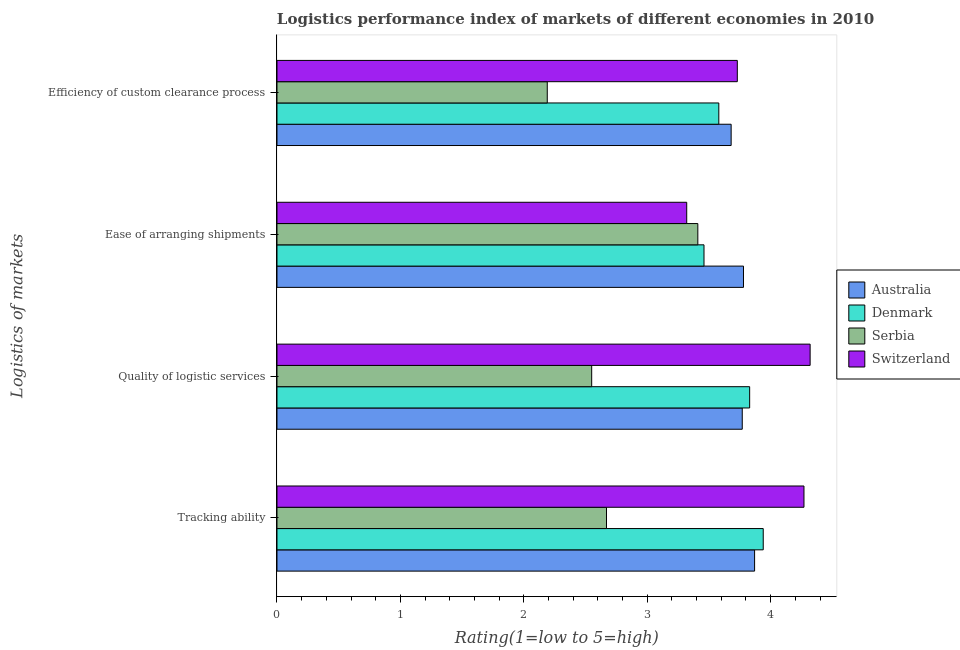Are the number of bars per tick equal to the number of legend labels?
Your response must be concise. Yes. How many bars are there on the 3rd tick from the top?
Keep it short and to the point. 4. What is the label of the 2nd group of bars from the top?
Provide a short and direct response. Ease of arranging shipments. What is the lpi rating of efficiency of custom clearance process in Australia?
Offer a very short reply. 3.68. Across all countries, what is the maximum lpi rating of tracking ability?
Provide a short and direct response. 4.27. Across all countries, what is the minimum lpi rating of efficiency of custom clearance process?
Your answer should be compact. 2.19. In which country was the lpi rating of efficiency of custom clearance process minimum?
Offer a terse response. Serbia. What is the total lpi rating of ease of arranging shipments in the graph?
Provide a succinct answer. 13.97. What is the difference between the lpi rating of quality of logistic services in Australia and that in Serbia?
Your answer should be compact. 1.22. What is the difference between the lpi rating of efficiency of custom clearance process in Serbia and the lpi rating of ease of arranging shipments in Australia?
Give a very brief answer. -1.59. What is the average lpi rating of ease of arranging shipments per country?
Your answer should be very brief. 3.49. What is the difference between the lpi rating of ease of arranging shipments and lpi rating of tracking ability in Serbia?
Your answer should be very brief. 0.74. In how many countries, is the lpi rating of ease of arranging shipments greater than 2.2 ?
Your response must be concise. 4. What is the ratio of the lpi rating of efficiency of custom clearance process in Denmark to that in Switzerland?
Ensure brevity in your answer.  0.96. Is the lpi rating of quality of logistic services in Switzerland less than that in Serbia?
Make the answer very short. No. What is the difference between the highest and the second highest lpi rating of quality of logistic services?
Your answer should be compact. 0.49. What is the difference between the highest and the lowest lpi rating of tracking ability?
Provide a succinct answer. 1.6. In how many countries, is the lpi rating of ease of arranging shipments greater than the average lpi rating of ease of arranging shipments taken over all countries?
Give a very brief answer. 1. Is it the case that in every country, the sum of the lpi rating of tracking ability and lpi rating of ease of arranging shipments is greater than the sum of lpi rating of efficiency of custom clearance process and lpi rating of quality of logistic services?
Keep it short and to the point. No. What does the 2nd bar from the top in Tracking ability represents?
Keep it short and to the point. Serbia. Is it the case that in every country, the sum of the lpi rating of tracking ability and lpi rating of quality of logistic services is greater than the lpi rating of ease of arranging shipments?
Offer a terse response. Yes. How many bars are there?
Offer a very short reply. 16. Are all the bars in the graph horizontal?
Offer a very short reply. Yes. Does the graph contain any zero values?
Offer a terse response. No. Does the graph contain grids?
Ensure brevity in your answer.  No. How many legend labels are there?
Ensure brevity in your answer.  4. What is the title of the graph?
Your response must be concise. Logistics performance index of markets of different economies in 2010. What is the label or title of the X-axis?
Provide a short and direct response. Rating(1=low to 5=high). What is the label or title of the Y-axis?
Provide a short and direct response. Logistics of markets. What is the Rating(1=low to 5=high) in Australia in Tracking ability?
Keep it short and to the point. 3.87. What is the Rating(1=low to 5=high) of Denmark in Tracking ability?
Your answer should be compact. 3.94. What is the Rating(1=low to 5=high) in Serbia in Tracking ability?
Your answer should be very brief. 2.67. What is the Rating(1=low to 5=high) in Switzerland in Tracking ability?
Ensure brevity in your answer.  4.27. What is the Rating(1=low to 5=high) in Australia in Quality of logistic services?
Offer a very short reply. 3.77. What is the Rating(1=low to 5=high) in Denmark in Quality of logistic services?
Your answer should be compact. 3.83. What is the Rating(1=low to 5=high) in Serbia in Quality of logistic services?
Give a very brief answer. 2.55. What is the Rating(1=low to 5=high) in Switzerland in Quality of logistic services?
Your response must be concise. 4.32. What is the Rating(1=low to 5=high) of Australia in Ease of arranging shipments?
Keep it short and to the point. 3.78. What is the Rating(1=low to 5=high) of Denmark in Ease of arranging shipments?
Provide a short and direct response. 3.46. What is the Rating(1=low to 5=high) in Serbia in Ease of arranging shipments?
Ensure brevity in your answer.  3.41. What is the Rating(1=low to 5=high) in Switzerland in Ease of arranging shipments?
Give a very brief answer. 3.32. What is the Rating(1=low to 5=high) in Australia in Efficiency of custom clearance process?
Offer a terse response. 3.68. What is the Rating(1=low to 5=high) of Denmark in Efficiency of custom clearance process?
Provide a short and direct response. 3.58. What is the Rating(1=low to 5=high) in Serbia in Efficiency of custom clearance process?
Keep it short and to the point. 2.19. What is the Rating(1=low to 5=high) in Switzerland in Efficiency of custom clearance process?
Keep it short and to the point. 3.73. Across all Logistics of markets, what is the maximum Rating(1=low to 5=high) of Australia?
Offer a very short reply. 3.87. Across all Logistics of markets, what is the maximum Rating(1=low to 5=high) of Denmark?
Offer a terse response. 3.94. Across all Logistics of markets, what is the maximum Rating(1=low to 5=high) in Serbia?
Your answer should be very brief. 3.41. Across all Logistics of markets, what is the maximum Rating(1=low to 5=high) in Switzerland?
Your answer should be very brief. 4.32. Across all Logistics of markets, what is the minimum Rating(1=low to 5=high) of Australia?
Offer a terse response. 3.68. Across all Logistics of markets, what is the minimum Rating(1=low to 5=high) of Denmark?
Provide a succinct answer. 3.46. Across all Logistics of markets, what is the minimum Rating(1=low to 5=high) of Serbia?
Keep it short and to the point. 2.19. Across all Logistics of markets, what is the minimum Rating(1=low to 5=high) in Switzerland?
Provide a succinct answer. 3.32. What is the total Rating(1=low to 5=high) in Denmark in the graph?
Offer a very short reply. 14.81. What is the total Rating(1=low to 5=high) of Serbia in the graph?
Offer a terse response. 10.82. What is the total Rating(1=low to 5=high) of Switzerland in the graph?
Provide a short and direct response. 15.64. What is the difference between the Rating(1=low to 5=high) of Australia in Tracking ability and that in Quality of logistic services?
Your answer should be very brief. 0.1. What is the difference between the Rating(1=low to 5=high) of Denmark in Tracking ability and that in Quality of logistic services?
Provide a succinct answer. 0.11. What is the difference between the Rating(1=low to 5=high) of Serbia in Tracking ability and that in Quality of logistic services?
Offer a very short reply. 0.12. What is the difference between the Rating(1=low to 5=high) of Switzerland in Tracking ability and that in Quality of logistic services?
Keep it short and to the point. -0.05. What is the difference between the Rating(1=low to 5=high) of Australia in Tracking ability and that in Ease of arranging shipments?
Ensure brevity in your answer.  0.09. What is the difference between the Rating(1=low to 5=high) of Denmark in Tracking ability and that in Ease of arranging shipments?
Offer a very short reply. 0.48. What is the difference between the Rating(1=low to 5=high) of Serbia in Tracking ability and that in Ease of arranging shipments?
Keep it short and to the point. -0.74. What is the difference between the Rating(1=low to 5=high) of Switzerland in Tracking ability and that in Ease of arranging shipments?
Keep it short and to the point. 0.95. What is the difference between the Rating(1=low to 5=high) in Australia in Tracking ability and that in Efficiency of custom clearance process?
Give a very brief answer. 0.19. What is the difference between the Rating(1=low to 5=high) in Denmark in Tracking ability and that in Efficiency of custom clearance process?
Provide a succinct answer. 0.36. What is the difference between the Rating(1=low to 5=high) of Serbia in Tracking ability and that in Efficiency of custom clearance process?
Offer a terse response. 0.48. What is the difference between the Rating(1=low to 5=high) of Switzerland in Tracking ability and that in Efficiency of custom clearance process?
Your answer should be very brief. 0.54. What is the difference between the Rating(1=low to 5=high) in Australia in Quality of logistic services and that in Ease of arranging shipments?
Ensure brevity in your answer.  -0.01. What is the difference between the Rating(1=low to 5=high) of Denmark in Quality of logistic services and that in Ease of arranging shipments?
Keep it short and to the point. 0.37. What is the difference between the Rating(1=low to 5=high) in Serbia in Quality of logistic services and that in Ease of arranging shipments?
Your answer should be compact. -0.86. What is the difference between the Rating(1=low to 5=high) of Switzerland in Quality of logistic services and that in Ease of arranging shipments?
Offer a very short reply. 1. What is the difference between the Rating(1=low to 5=high) in Australia in Quality of logistic services and that in Efficiency of custom clearance process?
Your answer should be very brief. 0.09. What is the difference between the Rating(1=low to 5=high) in Serbia in Quality of logistic services and that in Efficiency of custom clearance process?
Make the answer very short. 0.36. What is the difference between the Rating(1=low to 5=high) of Switzerland in Quality of logistic services and that in Efficiency of custom clearance process?
Keep it short and to the point. 0.59. What is the difference between the Rating(1=low to 5=high) of Denmark in Ease of arranging shipments and that in Efficiency of custom clearance process?
Provide a short and direct response. -0.12. What is the difference between the Rating(1=low to 5=high) of Serbia in Ease of arranging shipments and that in Efficiency of custom clearance process?
Your response must be concise. 1.22. What is the difference between the Rating(1=low to 5=high) in Switzerland in Ease of arranging shipments and that in Efficiency of custom clearance process?
Ensure brevity in your answer.  -0.41. What is the difference between the Rating(1=low to 5=high) of Australia in Tracking ability and the Rating(1=low to 5=high) of Serbia in Quality of logistic services?
Your response must be concise. 1.32. What is the difference between the Rating(1=low to 5=high) of Australia in Tracking ability and the Rating(1=low to 5=high) of Switzerland in Quality of logistic services?
Ensure brevity in your answer.  -0.45. What is the difference between the Rating(1=low to 5=high) of Denmark in Tracking ability and the Rating(1=low to 5=high) of Serbia in Quality of logistic services?
Your response must be concise. 1.39. What is the difference between the Rating(1=low to 5=high) in Denmark in Tracking ability and the Rating(1=low to 5=high) in Switzerland in Quality of logistic services?
Your answer should be very brief. -0.38. What is the difference between the Rating(1=low to 5=high) in Serbia in Tracking ability and the Rating(1=low to 5=high) in Switzerland in Quality of logistic services?
Offer a very short reply. -1.65. What is the difference between the Rating(1=low to 5=high) in Australia in Tracking ability and the Rating(1=low to 5=high) in Denmark in Ease of arranging shipments?
Your response must be concise. 0.41. What is the difference between the Rating(1=low to 5=high) in Australia in Tracking ability and the Rating(1=low to 5=high) in Serbia in Ease of arranging shipments?
Your answer should be very brief. 0.46. What is the difference between the Rating(1=low to 5=high) in Australia in Tracking ability and the Rating(1=low to 5=high) in Switzerland in Ease of arranging shipments?
Ensure brevity in your answer.  0.55. What is the difference between the Rating(1=low to 5=high) of Denmark in Tracking ability and the Rating(1=low to 5=high) of Serbia in Ease of arranging shipments?
Offer a very short reply. 0.53. What is the difference between the Rating(1=low to 5=high) of Denmark in Tracking ability and the Rating(1=low to 5=high) of Switzerland in Ease of arranging shipments?
Your response must be concise. 0.62. What is the difference between the Rating(1=low to 5=high) in Serbia in Tracking ability and the Rating(1=low to 5=high) in Switzerland in Ease of arranging shipments?
Your answer should be very brief. -0.65. What is the difference between the Rating(1=low to 5=high) in Australia in Tracking ability and the Rating(1=low to 5=high) in Denmark in Efficiency of custom clearance process?
Keep it short and to the point. 0.29. What is the difference between the Rating(1=low to 5=high) of Australia in Tracking ability and the Rating(1=low to 5=high) of Serbia in Efficiency of custom clearance process?
Offer a terse response. 1.68. What is the difference between the Rating(1=low to 5=high) in Australia in Tracking ability and the Rating(1=low to 5=high) in Switzerland in Efficiency of custom clearance process?
Make the answer very short. 0.14. What is the difference between the Rating(1=low to 5=high) of Denmark in Tracking ability and the Rating(1=low to 5=high) of Serbia in Efficiency of custom clearance process?
Give a very brief answer. 1.75. What is the difference between the Rating(1=low to 5=high) of Denmark in Tracking ability and the Rating(1=low to 5=high) of Switzerland in Efficiency of custom clearance process?
Offer a terse response. 0.21. What is the difference between the Rating(1=low to 5=high) in Serbia in Tracking ability and the Rating(1=low to 5=high) in Switzerland in Efficiency of custom clearance process?
Your response must be concise. -1.06. What is the difference between the Rating(1=low to 5=high) in Australia in Quality of logistic services and the Rating(1=low to 5=high) in Denmark in Ease of arranging shipments?
Offer a terse response. 0.31. What is the difference between the Rating(1=low to 5=high) in Australia in Quality of logistic services and the Rating(1=low to 5=high) in Serbia in Ease of arranging shipments?
Offer a terse response. 0.36. What is the difference between the Rating(1=low to 5=high) of Australia in Quality of logistic services and the Rating(1=low to 5=high) of Switzerland in Ease of arranging shipments?
Your answer should be very brief. 0.45. What is the difference between the Rating(1=low to 5=high) in Denmark in Quality of logistic services and the Rating(1=low to 5=high) in Serbia in Ease of arranging shipments?
Your answer should be compact. 0.42. What is the difference between the Rating(1=low to 5=high) in Denmark in Quality of logistic services and the Rating(1=low to 5=high) in Switzerland in Ease of arranging shipments?
Provide a short and direct response. 0.51. What is the difference between the Rating(1=low to 5=high) of Serbia in Quality of logistic services and the Rating(1=low to 5=high) of Switzerland in Ease of arranging shipments?
Offer a terse response. -0.77. What is the difference between the Rating(1=low to 5=high) in Australia in Quality of logistic services and the Rating(1=low to 5=high) in Denmark in Efficiency of custom clearance process?
Make the answer very short. 0.19. What is the difference between the Rating(1=low to 5=high) of Australia in Quality of logistic services and the Rating(1=low to 5=high) of Serbia in Efficiency of custom clearance process?
Ensure brevity in your answer.  1.58. What is the difference between the Rating(1=low to 5=high) in Australia in Quality of logistic services and the Rating(1=low to 5=high) in Switzerland in Efficiency of custom clearance process?
Offer a very short reply. 0.04. What is the difference between the Rating(1=low to 5=high) of Denmark in Quality of logistic services and the Rating(1=low to 5=high) of Serbia in Efficiency of custom clearance process?
Offer a terse response. 1.64. What is the difference between the Rating(1=low to 5=high) of Denmark in Quality of logistic services and the Rating(1=low to 5=high) of Switzerland in Efficiency of custom clearance process?
Ensure brevity in your answer.  0.1. What is the difference between the Rating(1=low to 5=high) in Serbia in Quality of logistic services and the Rating(1=low to 5=high) in Switzerland in Efficiency of custom clearance process?
Your answer should be compact. -1.18. What is the difference between the Rating(1=low to 5=high) of Australia in Ease of arranging shipments and the Rating(1=low to 5=high) of Denmark in Efficiency of custom clearance process?
Provide a succinct answer. 0.2. What is the difference between the Rating(1=low to 5=high) of Australia in Ease of arranging shipments and the Rating(1=low to 5=high) of Serbia in Efficiency of custom clearance process?
Give a very brief answer. 1.59. What is the difference between the Rating(1=low to 5=high) in Denmark in Ease of arranging shipments and the Rating(1=low to 5=high) in Serbia in Efficiency of custom clearance process?
Give a very brief answer. 1.27. What is the difference between the Rating(1=low to 5=high) in Denmark in Ease of arranging shipments and the Rating(1=low to 5=high) in Switzerland in Efficiency of custom clearance process?
Your answer should be very brief. -0.27. What is the difference between the Rating(1=low to 5=high) of Serbia in Ease of arranging shipments and the Rating(1=low to 5=high) of Switzerland in Efficiency of custom clearance process?
Provide a succinct answer. -0.32. What is the average Rating(1=low to 5=high) in Australia per Logistics of markets?
Offer a very short reply. 3.77. What is the average Rating(1=low to 5=high) in Denmark per Logistics of markets?
Provide a short and direct response. 3.7. What is the average Rating(1=low to 5=high) in Serbia per Logistics of markets?
Your answer should be very brief. 2.71. What is the average Rating(1=low to 5=high) of Switzerland per Logistics of markets?
Provide a succinct answer. 3.91. What is the difference between the Rating(1=low to 5=high) in Australia and Rating(1=low to 5=high) in Denmark in Tracking ability?
Provide a short and direct response. -0.07. What is the difference between the Rating(1=low to 5=high) in Australia and Rating(1=low to 5=high) in Serbia in Tracking ability?
Your answer should be very brief. 1.2. What is the difference between the Rating(1=low to 5=high) of Denmark and Rating(1=low to 5=high) of Serbia in Tracking ability?
Keep it short and to the point. 1.27. What is the difference between the Rating(1=low to 5=high) of Denmark and Rating(1=low to 5=high) of Switzerland in Tracking ability?
Offer a very short reply. -0.33. What is the difference between the Rating(1=low to 5=high) in Australia and Rating(1=low to 5=high) in Denmark in Quality of logistic services?
Make the answer very short. -0.06. What is the difference between the Rating(1=low to 5=high) of Australia and Rating(1=low to 5=high) of Serbia in Quality of logistic services?
Offer a terse response. 1.22. What is the difference between the Rating(1=low to 5=high) in Australia and Rating(1=low to 5=high) in Switzerland in Quality of logistic services?
Make the answer very short. -0.55. What is the difference between the Rating(1=low to 5=high) of Denmark and Rating(1=low to 5=high) of Serbia in Quality of logistic services?
Give a very brief answer. 1.28. What is the difference between the Rating(1=low to 5=high) of Denmark and Rating(1=low to 5=high) of Switzerland in Quality of logistic services?
Your answer should be very brief. -0.49. What is the difference between the Rating(1=low to 5=high) of Serbia and Rating(1=low to 5=high) of Switzerland in Quality of logistic services?
Offer a very short reply. -1.77. What is the difference between the Rating(1=low to 5=high) in Australia and Rating(1=low to 5=high) in Denmark in Ease of arranging shipments?
Ensure brevity in your answer.  0.32. What is the difference between the Rating(1=low to 5=high) of Australia and Rating(1=low to 5=high) of Serbia in Ease of arranging shipments?
Your answer should be compact. 0.37. What is the difference between the Rating(1=low to 5=high) in Australia and Rating(1=low to 5=high) in Switzerland in Ease of arranging shipments?
Your answer should be compact. 0.46. What is the difference between the Rating(1=low to 5=high) of Denmark and Rating(1=low to 5=high) of Serbia in Ease of arranging shipments?
Your answer should be very brief. 0.05. What is the difference between the Rating(1=low to 5=high) of Denmark and Rating(1=low to 5=high) of Switzerland in Ease of arranging shipments?
Provide a succinct answer. 0.14. What is the difference between the Rating(1=low to 5=high) in Serbia and Rating(1=low to 5=high) in Switzerland in Ease of arranging shipments?
Keep it short and to the point. 0.09. What is the difference between the Rating(1=low to 5=high) in Australia and Rating(1=low to 5=high) in Serbia in Efficiency of custom clearance process?
Offer a terse response. 1.49. What is the difference between the Rating(1=low to 5=high) of Denmark and Rating(1=low to 5=high) of Serbia in Efficiency of custom clearance process?
Provide a succinct answer. 1.39. What is the difference between the Rating(1=low to 5=high) of Serbia and Rating(1=low to 5=high) of Switzerland in Efficiency of custom clearance process?
Give a very brief answer. -1.54. What is the ratio of the Rating(1=low to 5=high) of Australia in Tracking ability to that in Quality of logistic services?
Ensure brevity in your answer.  1.03. What is the ratio of the Rating(1=low to 5=high) in Denmark in Tracking ability to that in Quality of logistic services?
Your answer should be very brief. 1.03. What is the ratio of the Rating(1=low to 5=high) of Serbia in Tracking ability to that in Quality of logistic services?
Provide a short and direct response. 1.05. What is the ratio of the Rating(1=low to 5=high) in Switzerland in Tracking ability to that in Quality of logistic services?
Make the answer very short. 0.99. What is the ratio of the Rating(1=low to 5=high) of Australia in Tracking ability to that in Ease of arranging shipments?
Your answer should be very brief. 1.02. What is the ratio of the Rating(1=low to 5=high) of Denmark in Tracking ability to that in Ease of arranging shipments?
Offer a very short reply. 1.14. What is the ratio of the Rating(1=low to 5=high) of Serbia in Tracking ability to that in Ease of arranging shipments?
Your answer should be compact. 0.78. What is the ratio of the Rating(1=low to 5=high) in Switzerland in Tracking ability to that in Ease of arranging shipments?
Give a very brief answer. 1.29. What is the ratio of the Rating(1=low to 5=high) in Australia in Tracking ability to that in Efficiency of custom clearance process?
Offer a terse response. 1.05. What is the ratio of the Rating(1=low to 5=high) of Denmark in Tracking ability to that in Efficiency of custom clearance process?
Your response must be concise. 1.1. What is the ratio of the Rating(1=low to 5=high) of Serbia in Tracking ability to that in Efficiency of custom clearance process?
Your response must be concise. 1.22. What is the ratio of the Rating(1=low to 5=high) in Switzerland in Tracking ability to that in Efficiency of custom clearance process?
Make the answer very short. 1.14. What is the ratio of the Rating(1=low to 5=high) of Denmark in Quality of logistic services to that in Ease of arranging shipments?
Ensure brevity in your answer.  1.11. What is the ratio of the Rating(1=low to 5=high) of Serbia in Quality of logistic services to that in Ease of arranging shipments?
Provide a succinct answer. 0.75. What is the ratio of the Rating(1=low to 5=high) in Switzerland in Quality of logistic services to that in Ease of arranging shipments?
Provide a succinct answer. 1.3. What is the ratio of the Rating(1=low to 5=high) in Australia in Quality of logistic services to that in Efficiency of custom clearance process?
Your answer should be compact. 1.02. What is the ratio of the Rating(1=low to 5=high) in Denmark in Quality of logistic services to that in Efficiency of custom clearance process?
Your answer should be compact. 1.07. What is the ratio of the Rating(1=low to 5=high) in Serbia in Quality of logistic services to that in Efficiency of custom clearance process?
Keep it short and to the point. 1.16. What is the ratio of the Rating(1=low to 5=high) in Switzerland in Quality of logistic services to that in Efficiency of custom clearance process?
Keep it short and to the point. 1.16. What is the ratio of the Rating(1=low to 5=high) in Australia in Ease of arranging shipments to that in Efficiency of custom clearance process?
Provide a short and direct response. 1.03. What is the ratio of the Rating(1=low to 5=high) in Denmark in Ease of arranging shipments to that in Efficiency of custom clearance process?
Make the answer very short. 0.97. What is the ratio of the Rating(1=low to 5=high) in Serbia in Ease of arranging shipments to that in Efficiency of custom clearance process?
Offer a terse response. 1.56. What is the ratio of the Rating(1=low to 5=high) in Switzerland in Ease of arranging shipments to that in Efficiency of custom clearance process?
Your answer should be compact. 0.89. What is the difference between the highest and the second highest Rating(1=low to 5=high) of Australia?
Provide a succinct answer. 0.09. What is the difference between the highest and the second highest Rating(1=low to 5=high) in Denmark?
Your answer should be compact. 0.11. What is the difference between the highest and the second highest Rating(1=low to 5=high) in Serbia?
Offer a terse response. 0.74. What is the difference between the highest and the lowest Rating(1=low to 5=high) in Australia?
Your response must be concise. 0.19. What is the difference between the highest and the lowest Rating(1=low to 5=high) in Denmark?
Give a very brief answer. 0.48. What is the difference between the highest and the lowest Rating(1=low to 5=high) in Serbia?
Offer a terse response. 1.22. What is the difference between the highest and the lowest Rating(1=low to 5=high) in Switzerland?
Offer a very short reply. 1. 